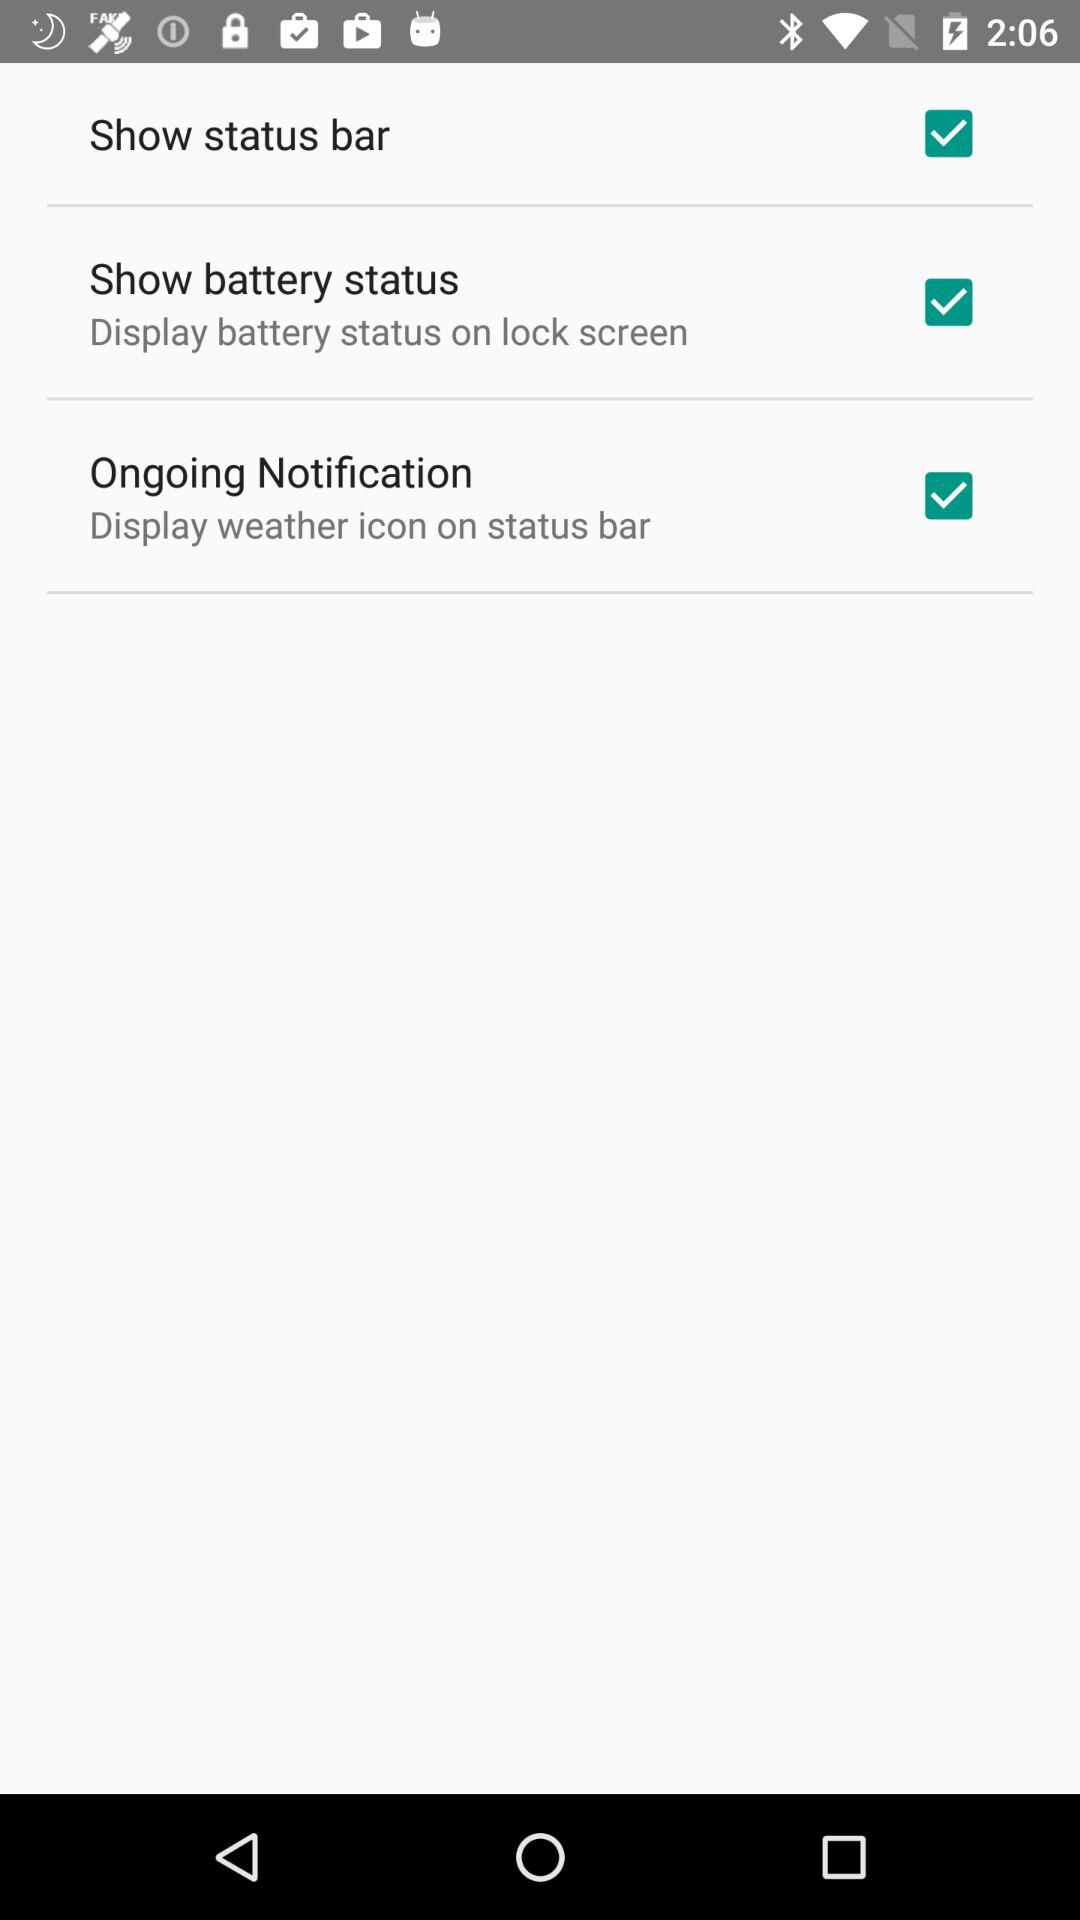Where will the weather icon be displayed? The weather icon will be displayed on the status bar. 